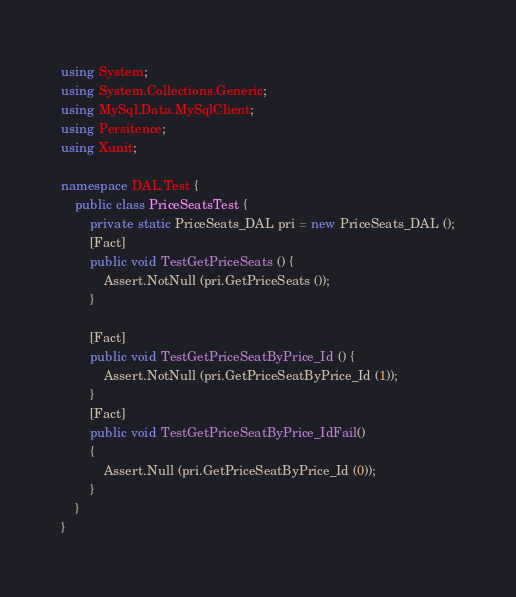<code> <loc_0><loc_0><loc_500><loc_500><_C#_>using System;
using System.Collections.Generic;
using MySql.Data.MySqlClient;
using Persitence;
using Xunit;

namespace DAL.Test {
    public class PriceSeatsTest {
        private static PriceSeats_DAL pri = new PriceSeats_DAL ();
        [Fact]
        public void TestGetPriceSeats () {
            Assert.NotNull (pri.GetPriceSeats ());
        }

        [Fact]
        public void TestGetPriceSeatByPrice_Id () {
            Assert.NotNull (pri.GetPriceSeatByPrice_Id (1));
        }
        [Fact]
        public void TestGetPriceSeatByPrice_IdFail()
        {
            Assert.Null (pri.GetPriceSeatByPrice_Id (0));
        }
    }
}</code> 